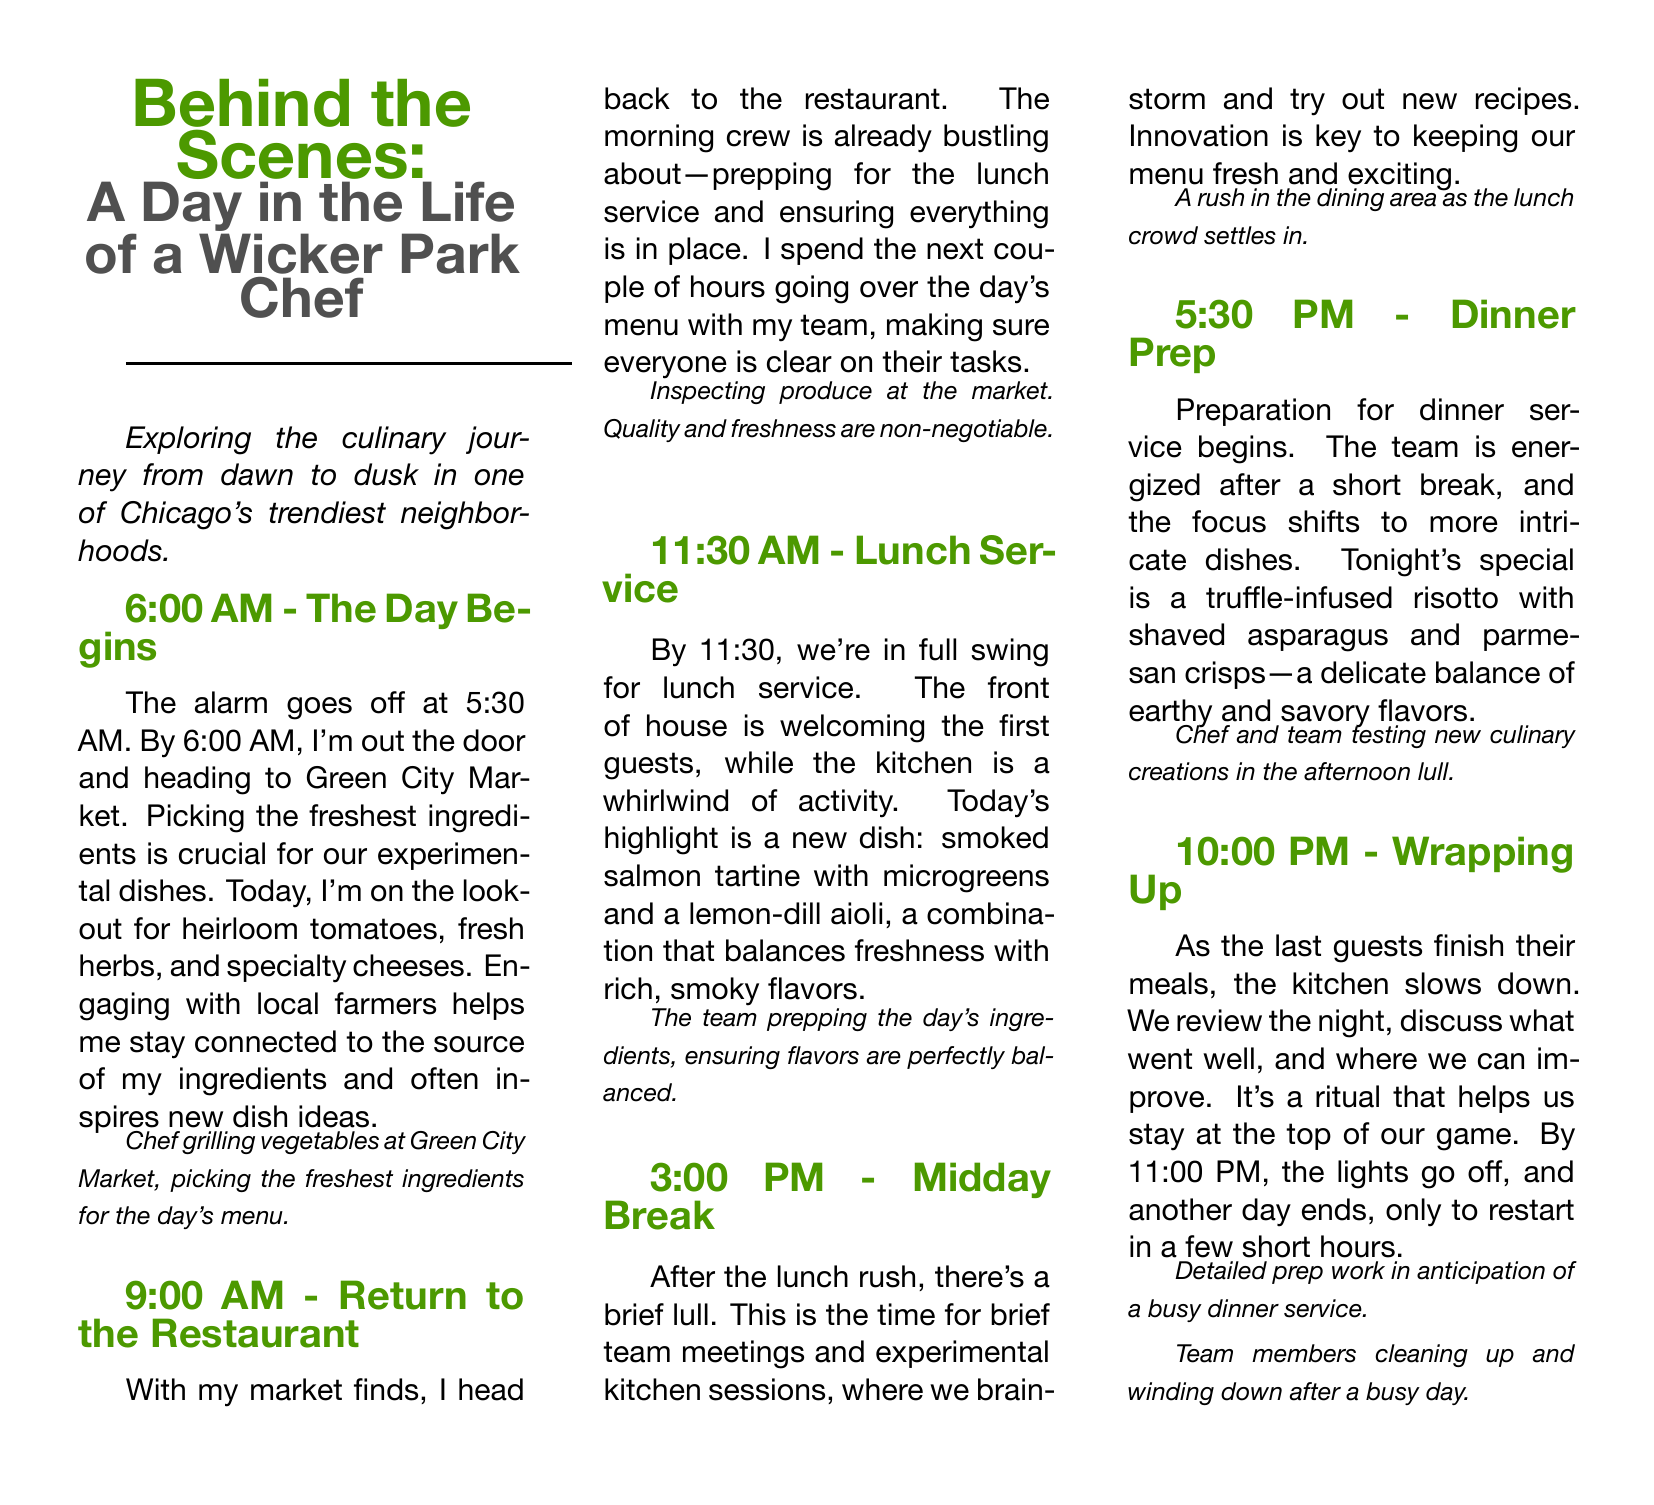What time does the chef wake up? The document states that the chef's alarm goes off at 5:30 AM.
Answer: 5:30 AM What is the first location the chef visits? The document mentions that the chef heads to Green City Market first thing in the morning.
Answer: Green City Market What is the special dish for dinner service? The document describes a truffle-infused risotto with shaved asparagus and parmesan crisps as tonight's special.
Answer: Truffle-infused risotto What time does lunch service start? The document indicates that lunch service begins at 11:30 AM.
Answer: 11:30 AM What type of dish is being highlighted for lunch? The document highlights a smoked salmon tartine as the new lunch dish.
Answer: Smoked salmon tartine What key activity occurs during the midday break? The document mentions that during the midday break, the team holds brief meetings and experimental kitchen sessions.
Answer: Experimental kitchen sessions What color is the title text in the document? The title text is described as being in a green color, specifically referred to as "chefgreen."
Answer: chefgreen How does the chef describe the importance of ingredient quality? The document emphasizes that quality and freshness are non-negotiable for the chef.
Answer: Non-negotiable What is the time for wrapping up the kitchen work? According to the document, the kitchen starts wrapping up at 10:00 PM.
Answer: 10:00 PM 